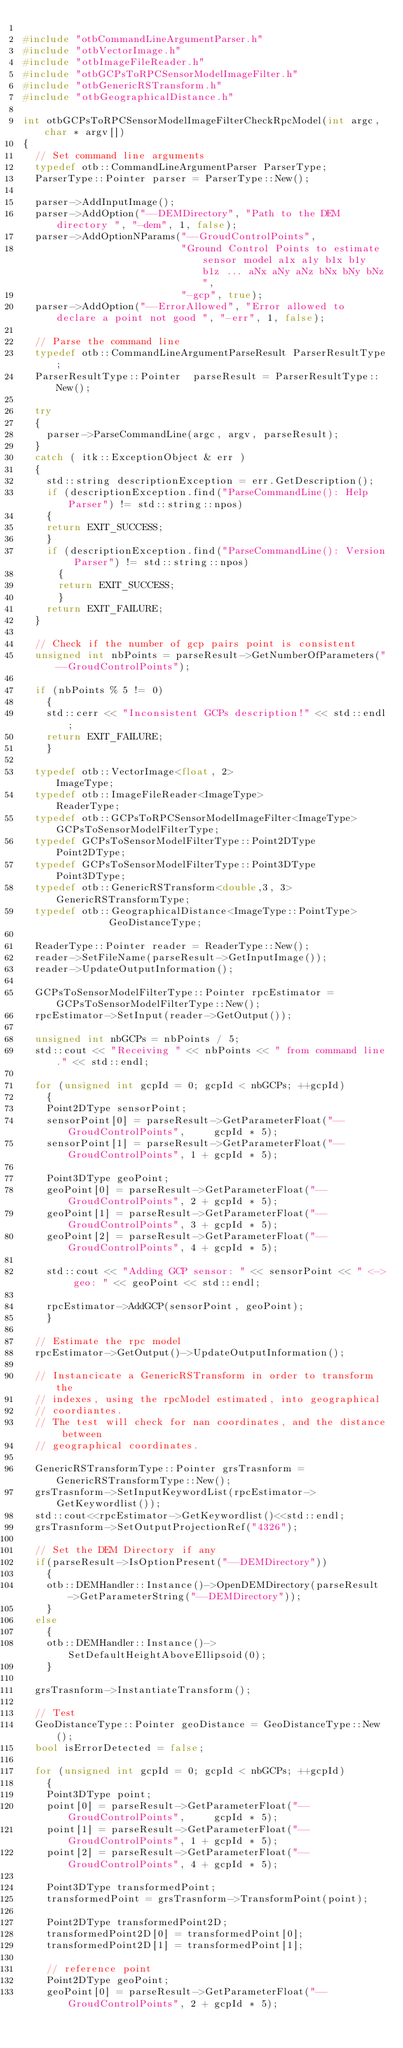Convert code to text. <code><loc_0><loc_0><loc_500><loc_500><_C++_>
#include "otbCommandLineArgumentParser.h"
#include "otbVectorImage.h"
#include "otbImageFileReader.h"
#include "otbGCPsToRPCSensorModelImageFilter.h"
#include "otbGenericRSTransform.h"
#include "otbGeographicalDistance.h"

int otbGCPsToRPCSensorModelImageFilterCheckRpcModel(int argc, char * argv[])
{
  // Set command line arguments
  typedef otb::CommandLineArgumentParser ParserType;
  ParserType::Pointer parser = ParserType::New();

  parser->AddInputImage();
  parser->AddOption("--DEMDirectory", "Path to the DEM directory ", "-dem", 1, false);
  parser->AddOptionNParams("--GroudControlPoints",
                           "Ground Control Points to estimate sensor model a1x a1y b1x b1y b1z ... aNx aNy aNz bNx bNy bNz",
                           "-gcp", true);
  parser->AddOption("--ErrorAllowed", "Error allowed to declare a point not good ", "-err", 1, false);

  // Parse the command line
  typedef otb::CommandLineArgumentParseResult ParserResultType;
  ParserResultType::Pointer  parseResult = ParserResultType::New();

  try
  {
    parser->ParseCommandLine(argc, argv, parseResult);
  }
  catch ( itk::ExceptionObject & err )
  {
    std::string descriptionException = err.GetDescription();
    if (descriptionException.find("ParseCommandLine(): Help Parser") != std::string::npos)
    {
    return EXIT_SUCCESS;
    }
    if (descriptionException.find("ParseCommandLine(): Version Parser") != std::string::npos)
      {
      return EXIT_SUCCESS;
      }
    return EXIT_FAILURE;
  }

  // Check if the number of gcp pairs point is consistent
  unsigned int nbPoints = parseResult->GetNumberOfParameters("--GroudControlPoints");

  if (nbPoints % 5 != 0)
    {
    std::cerr << "Inconsistent GCPs description!" << std::endl;
    return EXIT_FAILURE;
    }

  typedef otb::VectorImage<float, 2>                      ImageType;
  typedef otb::ImageFileReader<ImageType>                 ReaderType;
  typedef otb::GCPsToRPCSensorModelImageFilter<ImageType> GCPsToSensorModelFilterType;
  typedef GCPsToSensorModelFilterType::Point2DType        Point2DType;
  typedef GCPsToSensorModelFilterType::Point3DType        Point3DType;
  typedef otb::GenericRSTransform<double,3, 3>           GenericRSTransformType;
  typedef otb::GeographicalDistance<ImageType::PointType>          GeoDistanceType;

  ReaderType::Pointer reader = ReaderType::New();
  reader->SetFileName(parseResult->GetInputImage());
  reader->UpdateOutputInformation();

  GCPsToSensorModelFilterType::Pointer rpcEstimator = GCPsToSensorModelFilterType::New();
  rpcEstimator->SetInput(reader->GetOutput());

  unsigned int nbGCPs = nbPoints / 5;
  std::cout << "Receiving " << nbPoints << " from command line." << std::endl;

  for (unsigned int gcpId = 0; gcpId < nbGCPs; ++gcpId)
    {
    Point2DType sensorPoint;
    sensorPoint[0] = parseResult->GetParameterFloat("--GroudControlPoints",     gcpId * 5);
    sensorPoint[1] = parseResult->GetParameterFloat("--GroudControlPoints", 1 + gcpId * 5);

    Point3DType geoPoint;
    geoPoint[0] = parseResult->GetParameterFloat("--GroudControlPoints", 2 + gcpId * 5);
    geoPoint[1] = parseResult->GetParameterFloat("--GroudControlPoints", 3 + gcpId * 5);
    geoPoint[2] = parseResult->GetParameterFloat("--GroudControlPoints", 4 + gcpId * 5);

    std::cout << "Adding GCP sensor: " << sensorPoint << " <-> geo: " << geoPoint << std::endl;

    rpcEstimator->AddGCP(sensorPoint, geoPoint);
    }

  // Estimate the rpc model
  rpcEstimator->GetOutput()->UpdateOutputInformation();

  // Instancicate a GenericRSTransform in order to transform the
  // indexes, using the rpcModel estimated, into geographical
  // coordiantes.
  // The test will check for nan coordinates, and the distance between
  // geographical coordinates.

  GenericRSTransformType::Pointer grsTrasnform = GenericRSTransformType::New();
  grsTrasnform->SetInputKeywordList(rpcEstimator->GetKeywordlist());
  std::cout<<rpcEstimator->GetKeywordlist()<<std::endl;
  grsTrasnform->SetOutputProjectionRef("4326");

  // Set the DEM Directory if any
  if(parseResult->IsOptionPresent("--DEMDirectory"))
    {
    otb::DEMHandler::Instance()->OpenDEMDirectory(parseResult->GetParameterString("--DEMDirectory"));
    }
  else
    {
    otb::DEMHandler::Instance()->SetDefaultHeightAboveEllipsoid(0);
    }

  grsTrasnform->InstantiateTransform();

  // Test
  GeoDistanceType::Pointer geoDistance = GeoDistanceType::New();
  bool isErrorDetected = false;

  for (unsigned int gcpId = 0; gcpId < nbGCPs; ++gcpId)
    {
    Point3DType point;
    point[0] = parseResult->GetParameterFloat("--GroudControlPoints",     gcpId * 5);
    point[1] = parseResult->GetParameterFloat("--GroudControlPoints", 1 + gcpId * 5);
    point[2] = parseResult->GetParameterFloat("--GroudControlPoints", 4 + gcpId * 5);

    Point3DType transformedPoint;
    transformedPoint = grsTrasnform->TransformPoint(point);

    Point2DType transformedPoint2D;
    transformedPoint2D[0] = transformedPoint[0];
    transformedPoint2D[1] = transformedPoint[1];

    // reference point
    Point2DType geoPoint;
    geoPoint[0] = parseResult->GetParameterFloat("--GroudControlPoints", 2 + gcpId * 5);</code> 